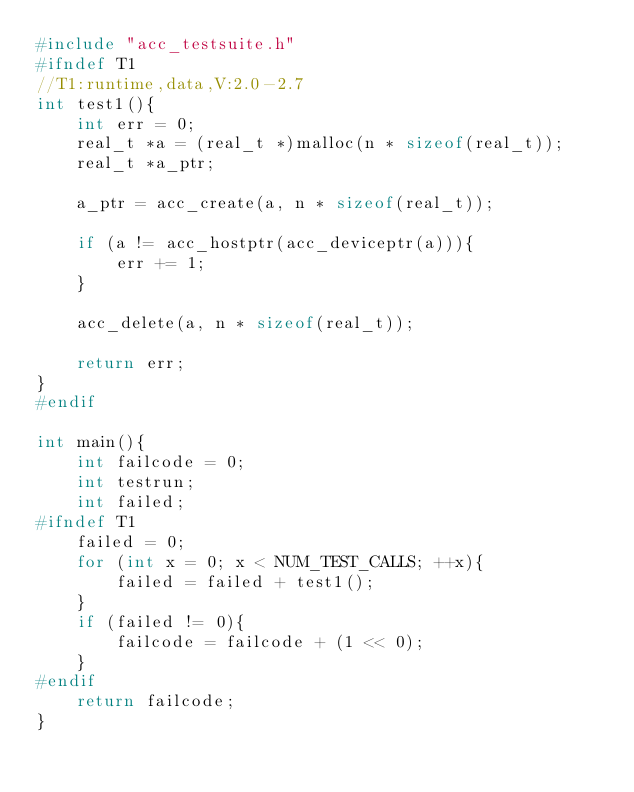<code> <loc_0><loc_0><loc_500><loc_500><_C_>#include "acc_testsuite.h"
#ifndef T1
//T1:runtime,data,V:2.0-2.7
int test1(){
    int err = 0;
    real_t *a = (real_t *)malloc(n * sizeof(real_t));
    real_t *a_ptr;

    a_ptr = acc_create(a, n * sizeof(real_t));

    if (a != acc_hostptr(acc_deviceptr(a))){
        err += 1;
    }

    acc_delete(a, n * sizeof(real_t));

    return err;
}
#endif

int main(){
    int failcode = 0;
    int testrun;
    int failed;
#ifndef T1
    failed = 0;
    for (int x = 0; x < NUM_TEST_CALLS; ++x){
        failed = failed + test1();
    }
    if (failed != 0){
        failcode = failcode + (1 << 0);
    }
#endif
    return failcode;
}
</code> 